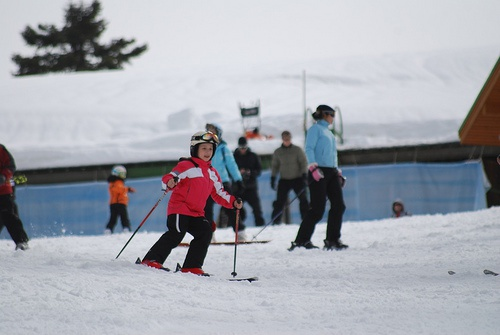Describe the objects in this image and their specific colors. I can see people in lightgray, black, brown, darkgray, and maroon tones, people in lightgray, black, and gray tones, people in lightgray, black, gray, and purple tones, people in lightgray, black, maroon, gray, and darkgray tones, and people in lightgray, black, gray, blue, and darkgray tones in this image. 